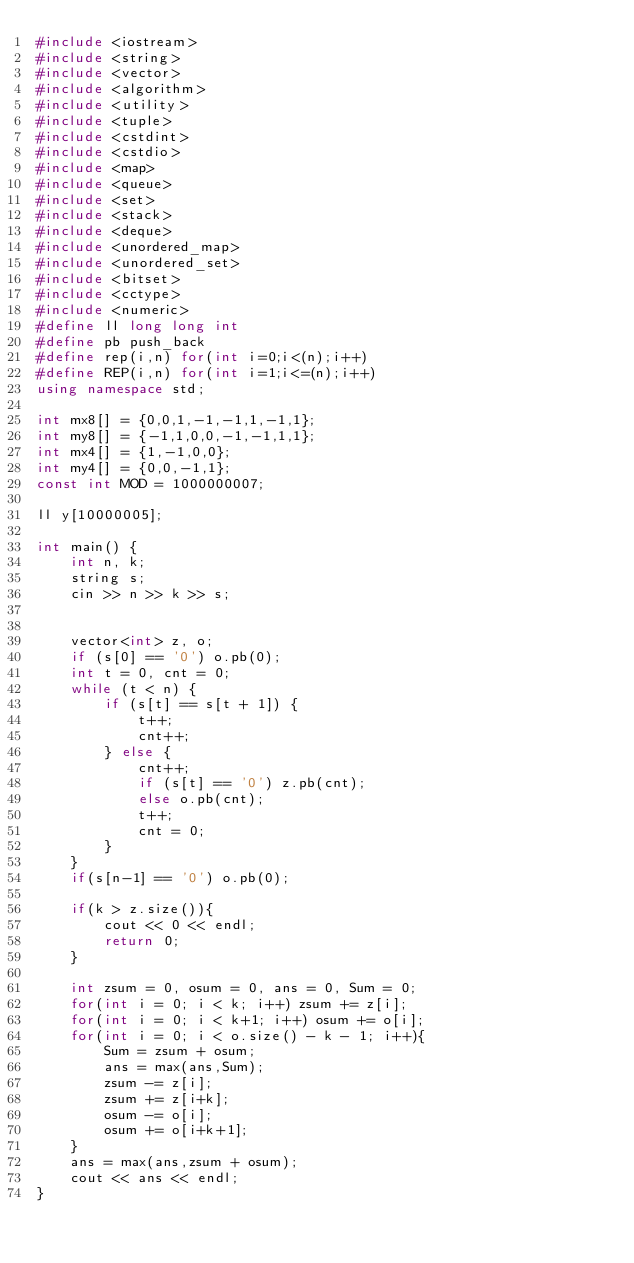<code> <loc_0><loc_0><loc_500><loc_500><_C++_>#include <iostream>
#include <string>
#include <vector>
#include <algorithm>
#include <utility>
#include <tuple>
#include <cstdint>
#include <cstdio>
#include <map>
#include <queue>
#include <set>
#include <stack>
#include <deque>
#include <unordered_map>
#include <unordered_set>
#include <bitset>
#include <cctype>
#include <numeric>
#define ll long long int
#define pb push_back
#define rep(i,n) for(int i=0;i<(n);i++)
#define REP(i,n) for(int i=1;i<=(n);i++)
using namespace std;

int mx8[] = {0,0,1,-1,-1,1,-1,1};
int my8[] = {-1,1,0,0,-1,-1,1,1};
int mx4[] = {1,-1,0,0};
int my4[] = {0,0,-1,1};
const int MOD = 1000000007;

ll y[10000005];

int main() {
    int n, k;
    string s;
    cin >> n >> k >> s;


    vector<int> z, o;
    if (s[0] == '0') o.pb(0);
    int t = 0, cnt = 0;
    while (t < n) {
        if (s[t] == s[t + 1]) {
            t++;
            cnt++;
        } else {
            cnt++;
            if (s[t] == '0') z.pb(cnt);
            else o.pb(cnt);
            t++;
            cnt = 0;
        }
    }
    if(s[n-1] == '0') o.pb(0);

    if(k > z.size()){
        cout << 0 << endl;
        return 0;
    }

    int zsum = 0, osum = 0, ans = 0, Sum = 0;
    for(int i = 0; i < k; i++) zsum += z[i];
    for(int i = 0; i < k+1; i++) osum += o[i];
    for(int i = 0; i < o.size() - k - 1; i++){
        Sum = zsum + osum;
        ans = max(ans,Sum);
        zsum -= z[i];
        zsum += z[i+k];
        osum -= o[i];
        osum += o[i+k+1];
    }
    ans = max(ans,zsum + osum);
    cout << ans << endl;
}</code> 